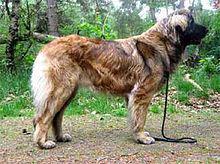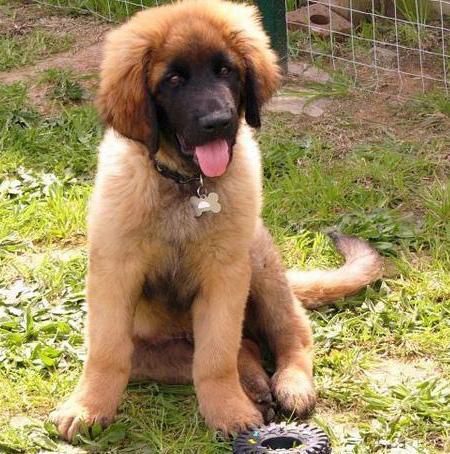The first image is the image on the left, the second image is the image on the right. Considering the images on both sides, is "There is a small child playing with a big dog." valid? Answer yes or no. No. 